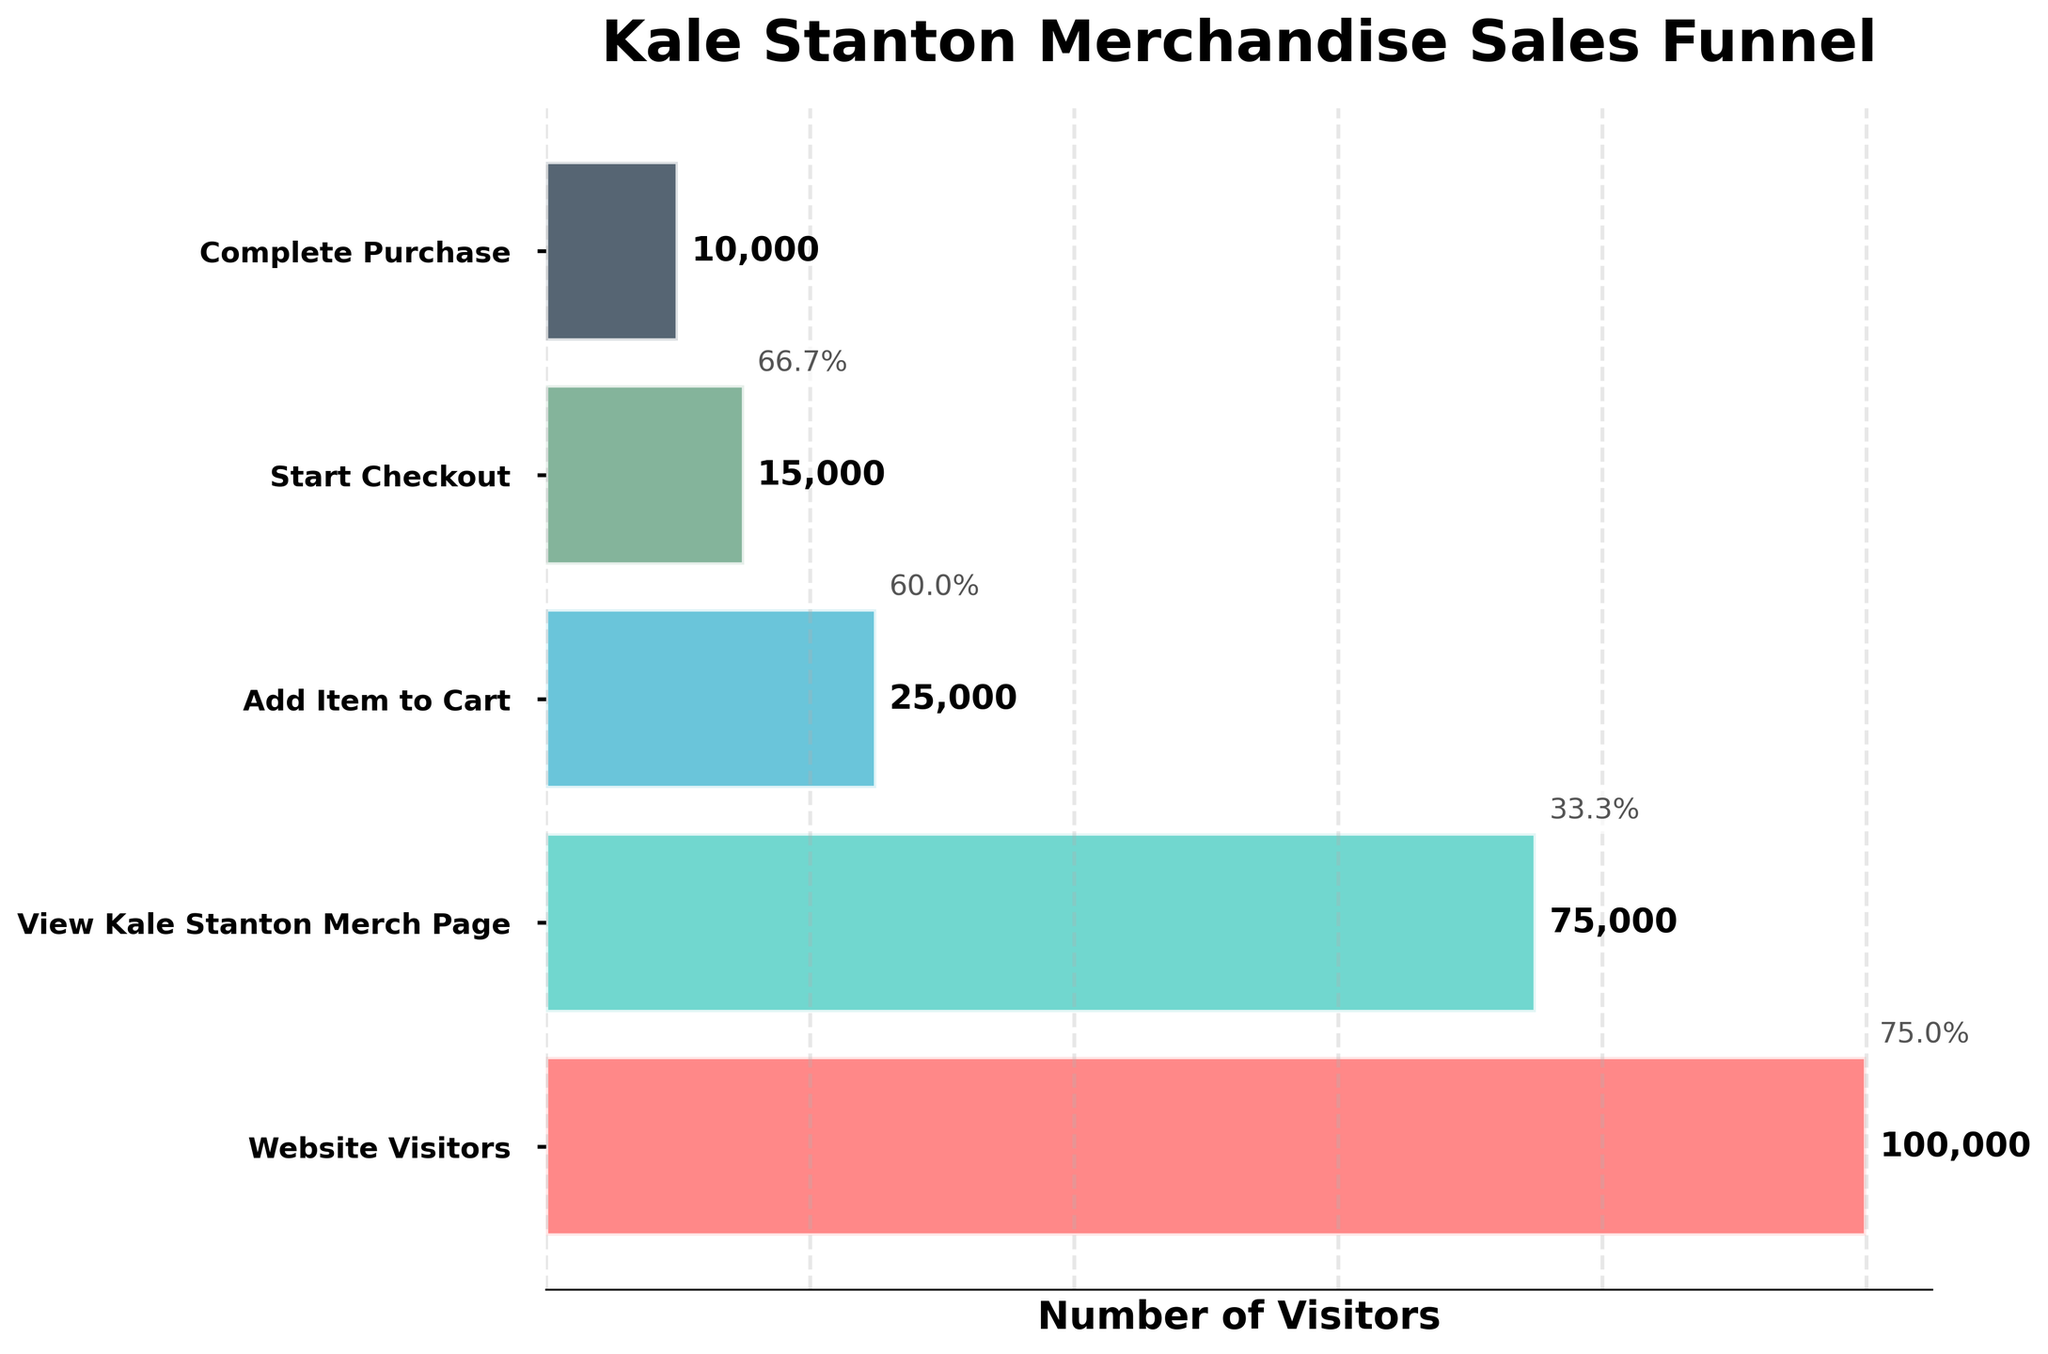What is the title of the plot? The title of the plot is typically located at the top and is prominently displayed in a larger font size
Answer: Kale Stanton Merchandise Sales Funnel How many stages are there in the funnel chart? You can count the number of labeled stages on the y-axis of the funnel chart
Answer: 5 How many website visitors does the funnel start with? The number of website visitors is the largest bar at the top of the funnel, often labeled
Answer: 100,000 Which stage has the lowest number of visitors? The narrowest bar at the bottom of the funnel represents the stage with the lowest number of visitors
Answer: Complete Purchase 